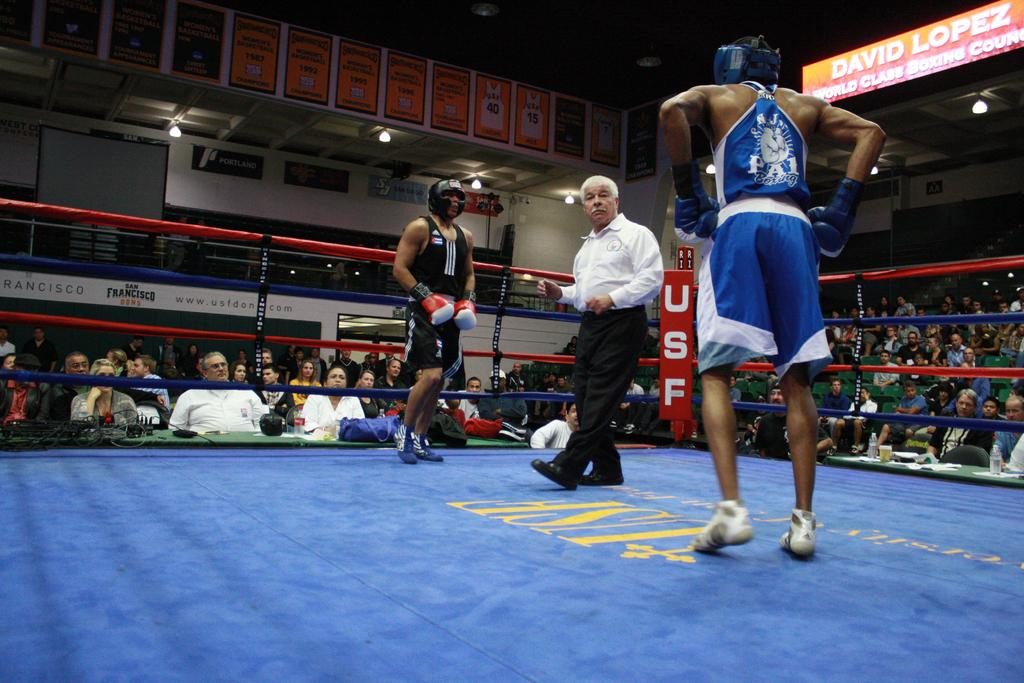<image>
Relay a brief, clear account of the picture shown. Two boxers in a boxing ring with USF displayed din the corner 